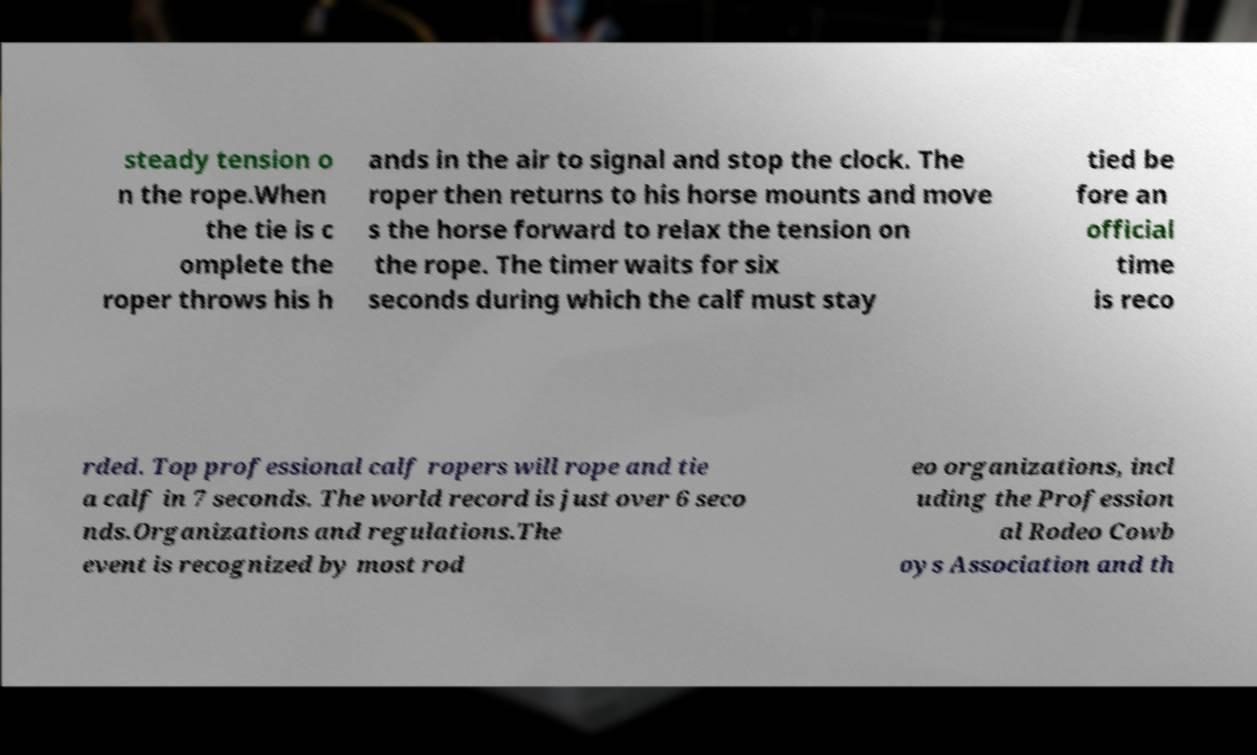I need the written content from this picture converted into text. Can you do that? steady tension o n the rope.When the tie is c omplete the roper throws his h ands in the air to signal and stop the clock. The roper then returns to his horse mounts and move s the horse forward to relax the tension on the rope. The timer waits for six seconds during which the calf must stay tied be fore an official time is reco rded. Top professional calf ropers will rope and tie a calf in 7 seconds. The world record is just over 6 seco nds.Organizations and regulations.The event is recognized by most rod eo organizations, incl uding the Profession al Rodeo Cowb oys Association and th 